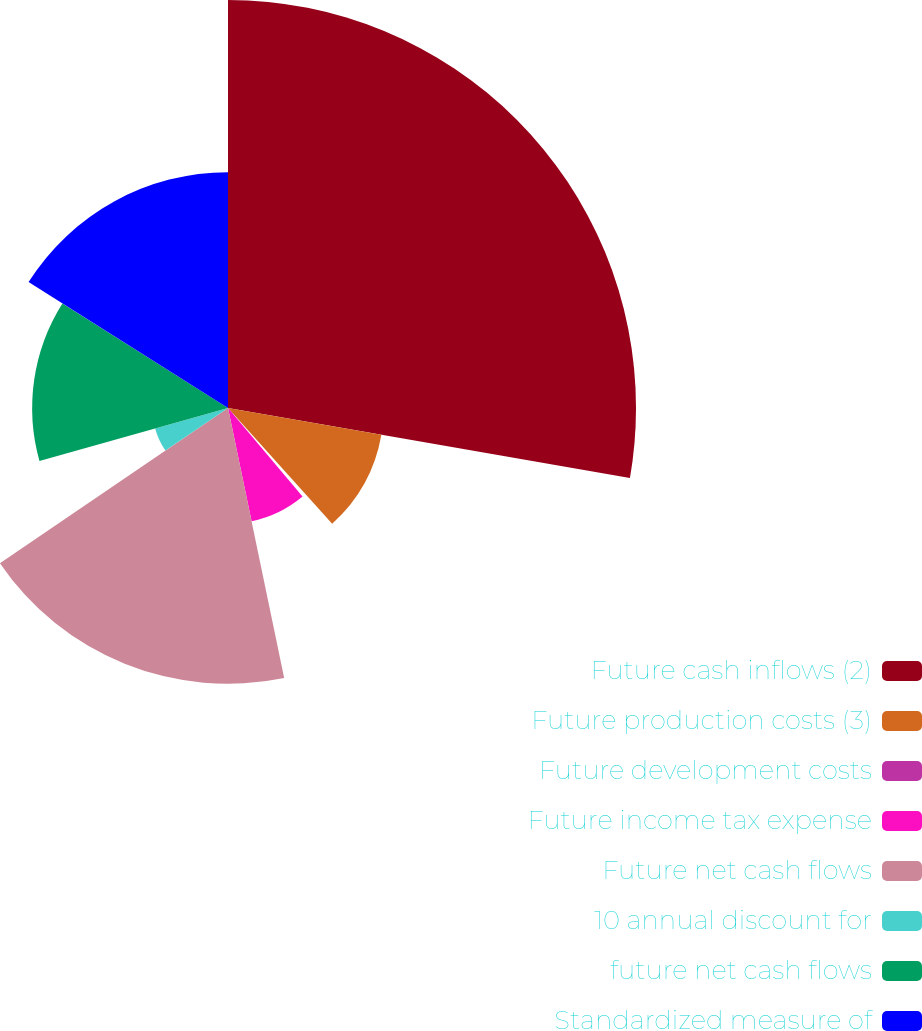Convert chart. <chart><loc_0><loc_0><loc_500><loc_500><pie_chart><fcel>Future cash inflows (2)<fcel>Future production costs (3)<fcel>Future development costs<fcel>Future income tax expense<fcel>Future net cash flows<fcel>10 annual discount for<fcel>future net cash flows<fcel>Standardized measure of<nl><fcel>27.75%<fcel>10.59%<fcel>0.53%<fcel>7.87%<fcel>18.76%<fcel>5.15%<fcel>13.32%<fcel>16.04%<nl></chart> 